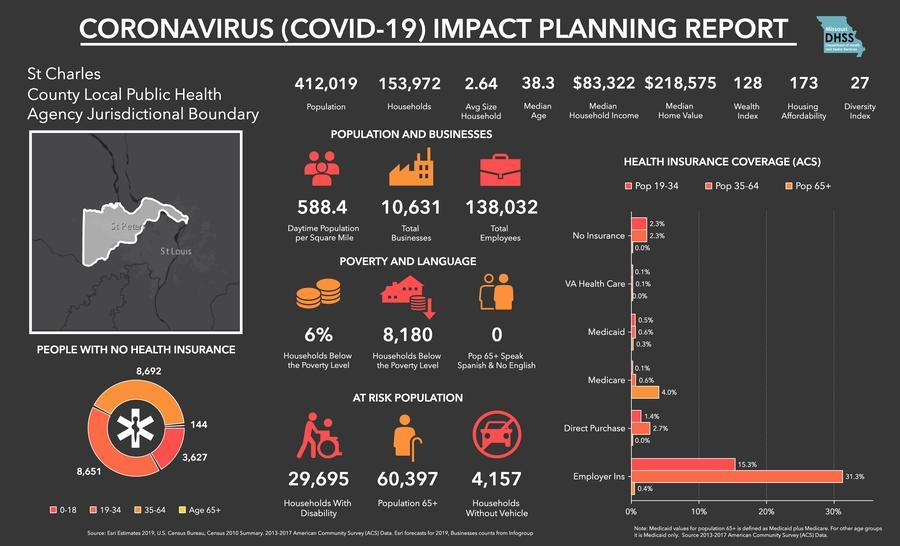What 'percent' of households fall below the poverty line?
Answer the question with a short phrase. 6% What percent of the population below 34 years, have no insurance? 2.3% What is the total number of households in the county? 153,972 Which age group has most number of 'people without health insurance'? 35-64 What is the average size of each household? 2.64 Which type of 'health insurance cover' do most of the senior citizens have? Medicare How many households have people with disability? 29,695 What percent of senior citizens have Direct purchase? 0.0% From the total households, how many households 'have vehicles'? 149,815 What percent of Pop 35-64 have VA health care? 0.1% How many households are without vehicle? 4,157 What is the total population of St Charles county? 412,019 How many senior citizens speak Spanish and no English? 0 How many households are there below the poverty line? 8,180 Which are the three types of households that fall under 'at-risk population'? Households with disability, population 65+, households without vehicle Which age group has the highest number of 'employer insurance' holders? Pop 35-64 What is the daytime population per square mile? 588.4 How many people below 18 years of age, have no health insurance? 3,627 Which are the two places shown on the map? St Peter, St Louis What is the total number of employees in St Charles county? 138,032 How many senior citizens have no health insurance? 144 What percent of senior citizens have Medicaid? 0.3% What is the total number of businesses in the county? 10,631 What is the diversity index of the county? 27 What is the median age? 38.3 What is the wealth index of the county? 128 What does the pie chart represent? People with no health insurance What percent of senior citizens have Medicare? 4.0 % 